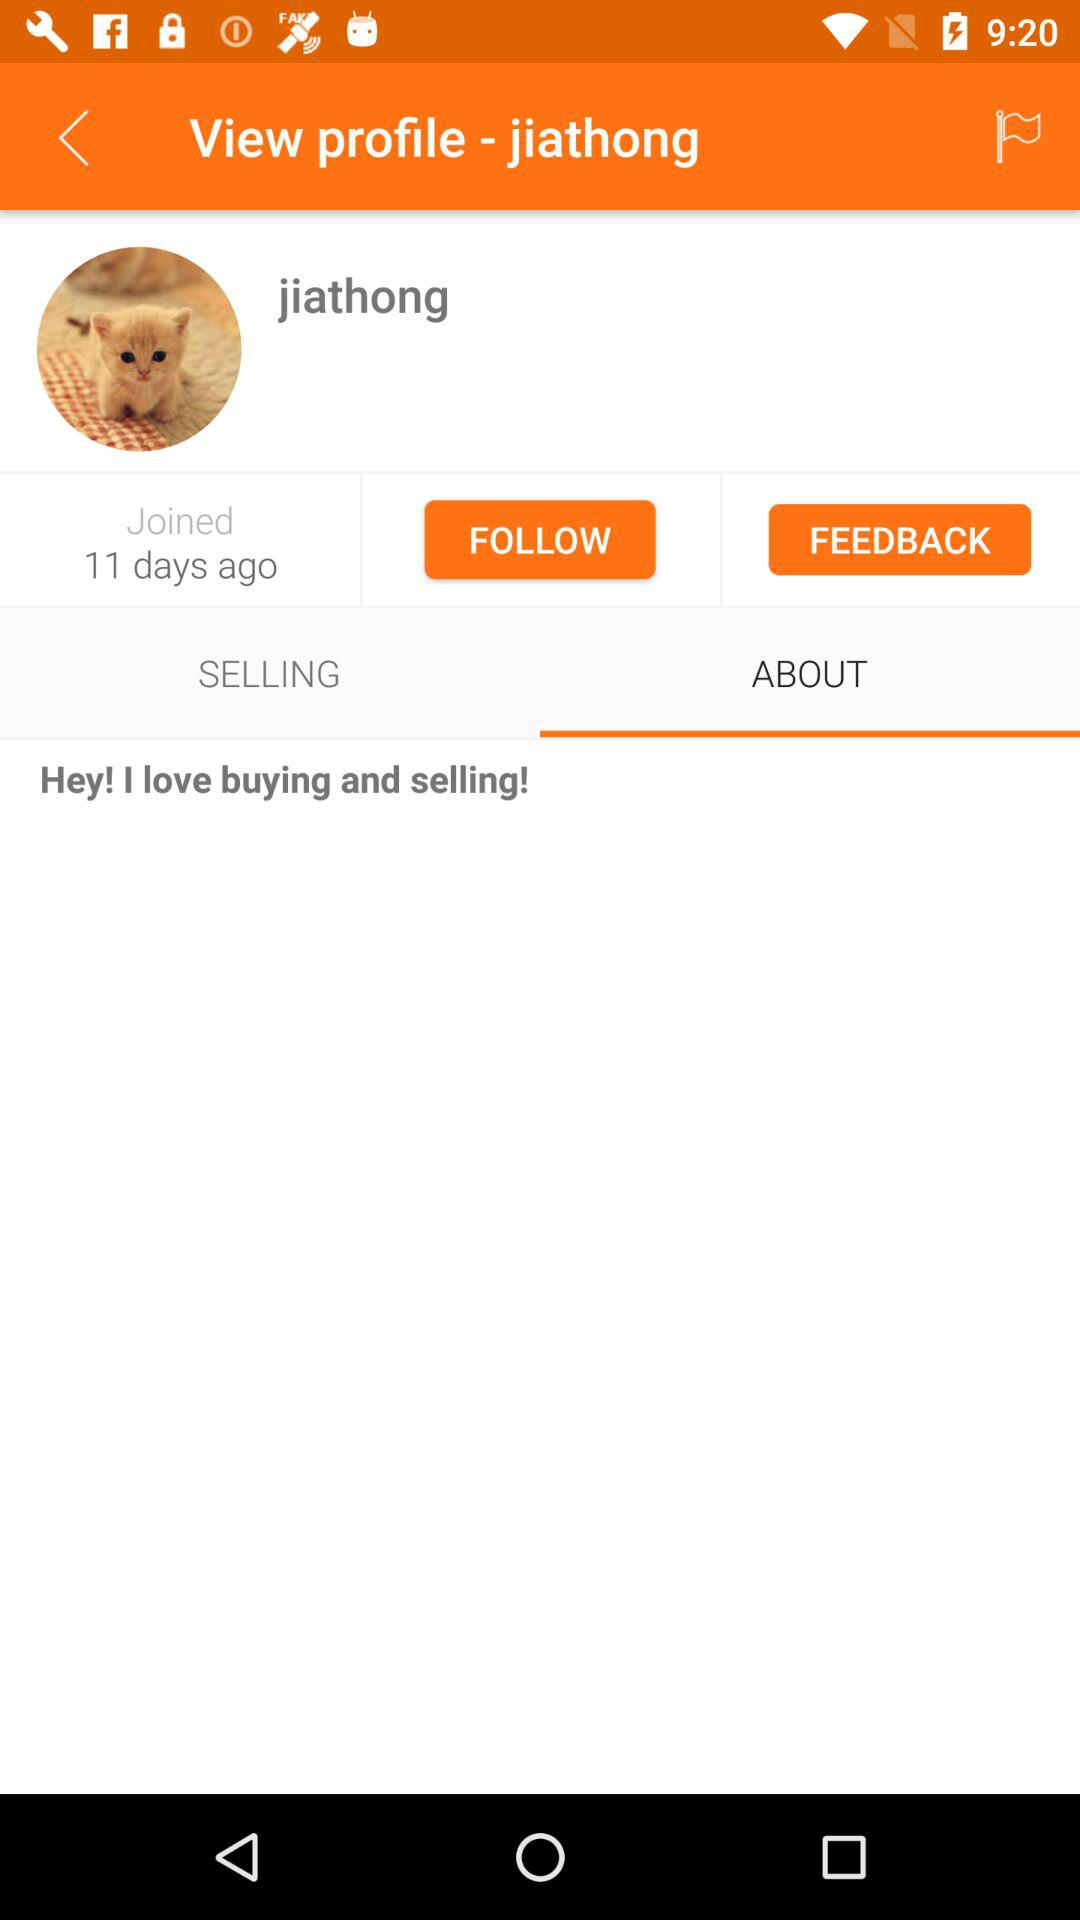Which tab is selected? The selected tab is "ABOUT". 